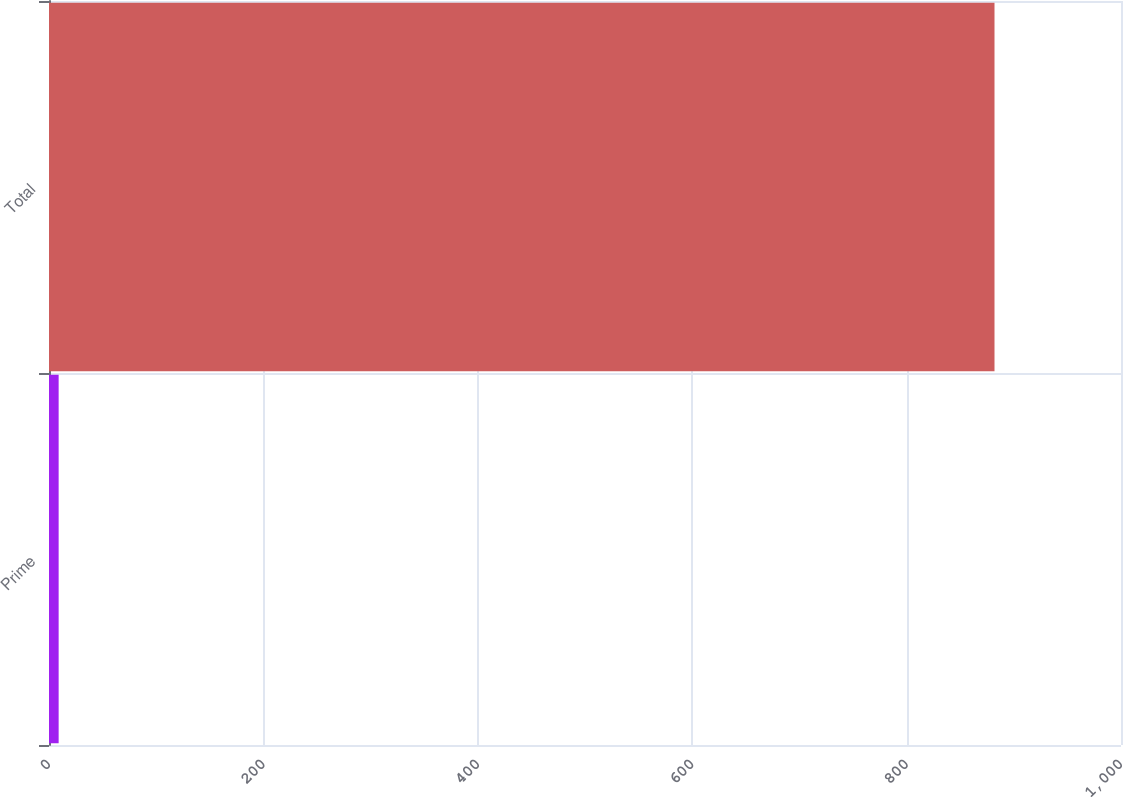<chart> <loc_0><loc_0><loc_500><loc_500><bar_chart><fcel>Prime<fcel>Total<nl><fcel>9<fcel>882<nl></chart> 